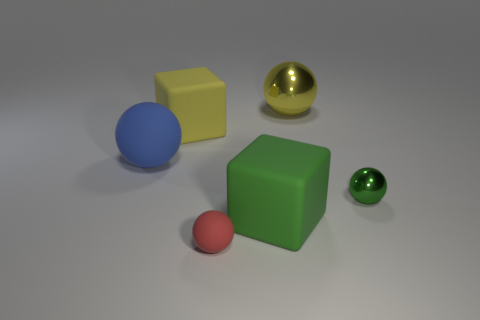Which of the objects in the image appears to be the largest? The green cube seems to be the largest object when considering its overall dimensions in the image. 